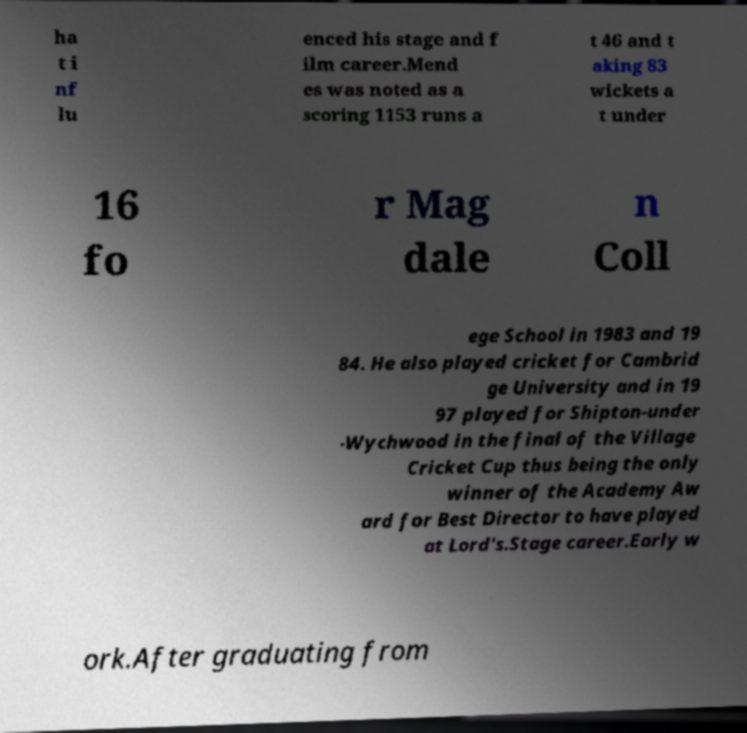Could you extract and type out the text from this image? ha t i nf lu enced his stage and f ilm career.Mend es was noted as a scoring 1153 runs a t 46 and t aking 83 wickets a t under 16 fo r Mag dale n Coll ege School in 1983 and 19 84. He also played cricket for Cambrid ge University and in 19 97 played for Shipton-under -Wychwood in the final of the Village Cricket Cup thus being the only winner of the Academy Aw ard for Best Director to have played at Lord's.Stage career.Early w ork.After graduating from 